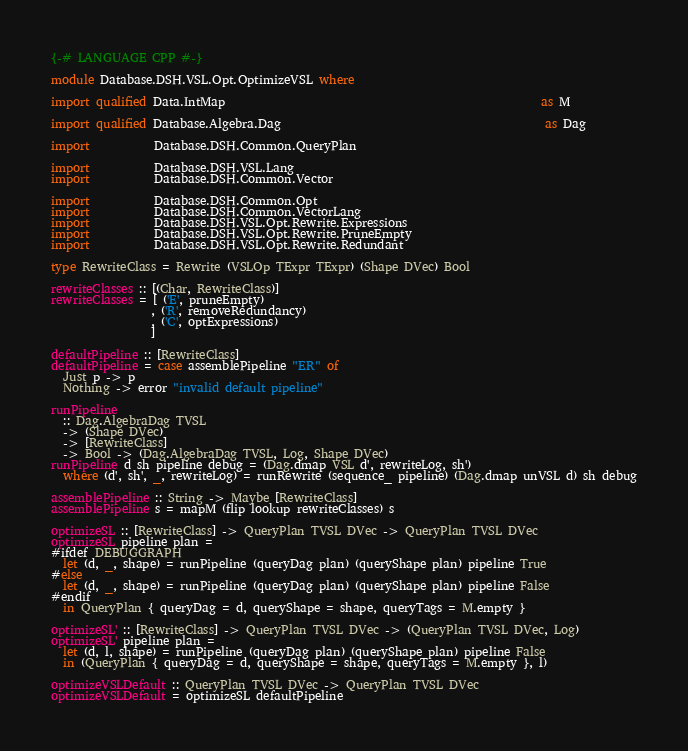Convert code to text. <code><loc_0><loc_0><loc_500><loc_500><_Haskell_>{-# LANGUAGE CPP #-}

module Database.DSH.VSL.Opt.OptimizeVSL where

import qualified Data.IntMap                                                      as M

import qualified Database.Algebra.Dag                                             as Dag

import           Database.DSH.Common.QueryPlan

import           Database.DSH.VSL.Lang
import           Database.DSH.Common.Vector

import           Database.DSH.Common.Opt
import           Database.DSH.Common.VectorLang
import           Database.DSH.VSL.Opt.Rewrite.Expressions
import           Database.DSH.VSL.Opt.Rewrite.PruneEmpty
import           Database.DSH.VSL.Opt.Rewrite.Redundant

type RewriteClass = Rewrite (VSLOp TExpr TExpr) (Shape DVec) Bool

rewriteClasses :: [(Char, RewriteClass)]
rewriteClasses = [ ('E', pruneEmpty)
                 , ('R', removeRedundancy)
                 , ('C', optExpressions)
                 ]

defaultPipeline :: [RewriteClass]
defaultPipeline = case assemblePipeline "ER" of
  Just p -> p
  Nothing -> error "invalid default pipeline"

runPipeline
  :: Dag.AlgebraDag TVSL
  -> (Shape DVec)
  -> [RewriteClass]
  -> Bool -> (Dag.AlgebraDag TVSL, Log, Shape DVec)
runPipeline d sh pipeline debug = (Dag.dmap VSL d', rewriteLog, sh')
  where (d', sh', _, rewriteLog) = runRewrite (sequence_ pipeline) (Dag.dmap unVSL d) sh debug

assemblePipeline :: String -> Maybe [RewriteClass]
assemblePipeline s = mapM (flip lookup rewriteClasses) s

optimizeSL :: [RewriteClass] -> QueryPlan TVSL DVec -> QueryPlan TVSL DVec
optimizeSL pipeline plan =
#ifdef DEBUGGRAPH
  let (d, _, shape) = runPipeline (queryDag plan) (queryShape plan) pipeline True
#else
  let (d, _, shape) = runPipeline (queryDag plan) (queryShape plan) pipeline False
#endif
  in QueryPlan { queryDag = d, queryShape = shape, queryTags = M.empty }

optimizeSL' :: [RewriteClass] -> QueryPlan TVSL DVec -> (QueryPlan TVSL DVec, Log)
optimizeSL' pipeline plan =
  let (d, l, shape) = runPipeline (queryDag plan) (queryShape plan) pipeline False
  in (QueryPlan { queryDag = d, queryShape = shape, queryTags = M.empty }, l)

optimizeVSLDefault :: QueryPlan TVSL DVec -> QueryPlan TVSL DVec
optimizeVSLDefault = optimizeSL defaultPipeline
</code> 